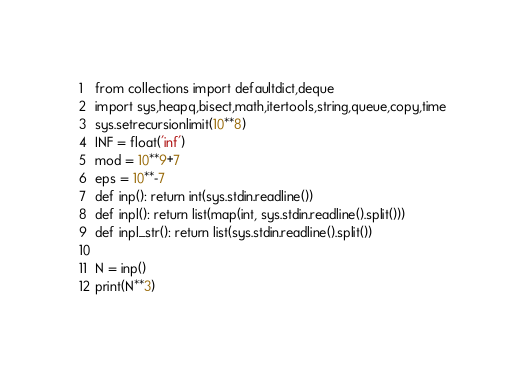<code> <loc_0><loc_0><loc_500><loc_500><_Python_>from collections import defaultdict,deque
import sys,heapq,bisect,math,itertools,string,queue,copy,time
sys.setrecursionlimit(10**8)
INF = float('inf')
mod = 10**9+7
eps = 10**-7
def inp(): return int(sys.stdin.readline())
def inpl(): return list(map(int, sys.stdin.readline().split()))
def inpl_str(): return list(sys.stdin.readline().split())

N = inp()
print(N**3)
</code> 